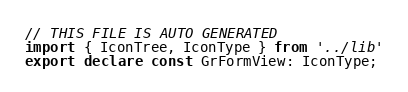<code> <loc_0><loc_0><loc_500><loc_500><_TypeScript_>// THIS FILE IS AUTO GENERATED
import { IconTree, IconType } from '../lib'
export declare const GrFormView: IconType;
</code> 